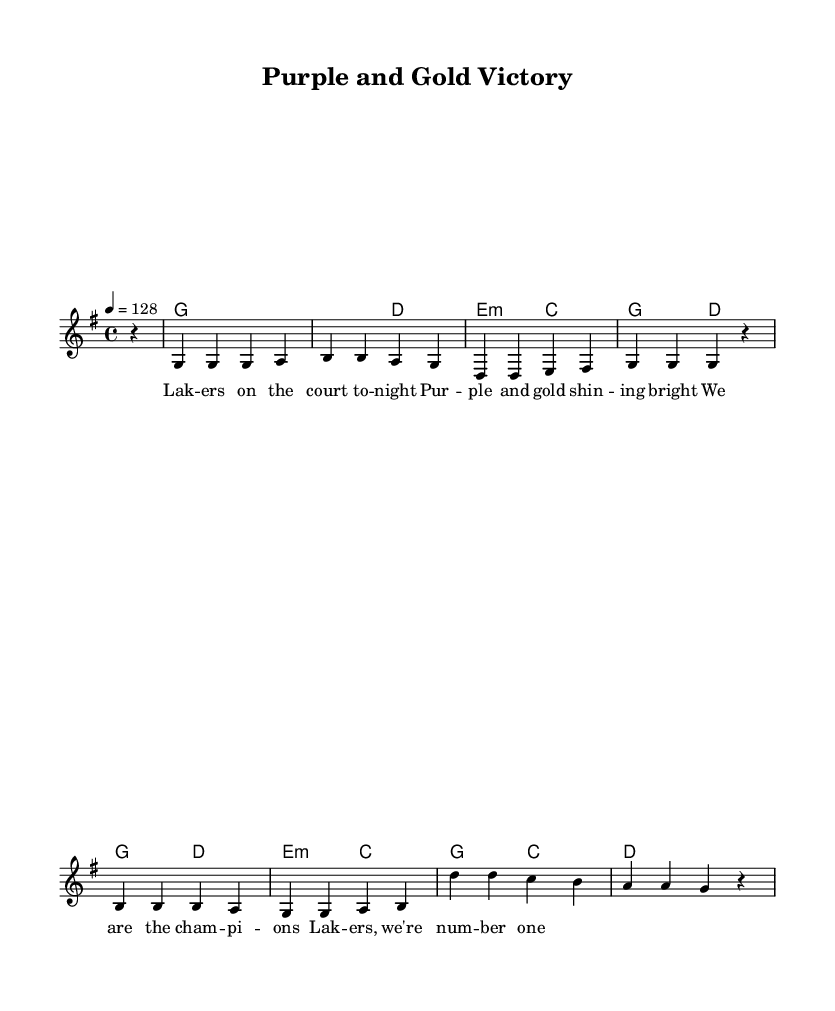What is the key signature of this music? The key signature shows two sharps, indicating that the key is G major.
Answer: G major What is the time signature of this music? The time signature appears at the beginning of the score and is written as 4/4, meaning there are four beats in each measure.
Answer: 4/4 What is the tempo marking for this piece? The tempo indicates a speed of 128 beats per minute, specified by the text "4 = 128".
Answer: 128 What is the last note of the chorus melody? Looking at the melody section, the last note is indicated as an "r", which signifies a rest.
Answer: Rest How many measures are in the verse section? Counting the measures in the verse, there are a total of four measures based on the melody line presented.
Answer: Four What is the scale degree of the second chord in the verse harmonies? The second chord in the verse is a D major chord, which is the V chord in G major.
Answer: V chord What is the lyrical theme of this anthem? The lyrics reflect pride in the Lakers team and celebrate their victory, focusing on team spirit and enthusiasm.
Answer: Team spirit 